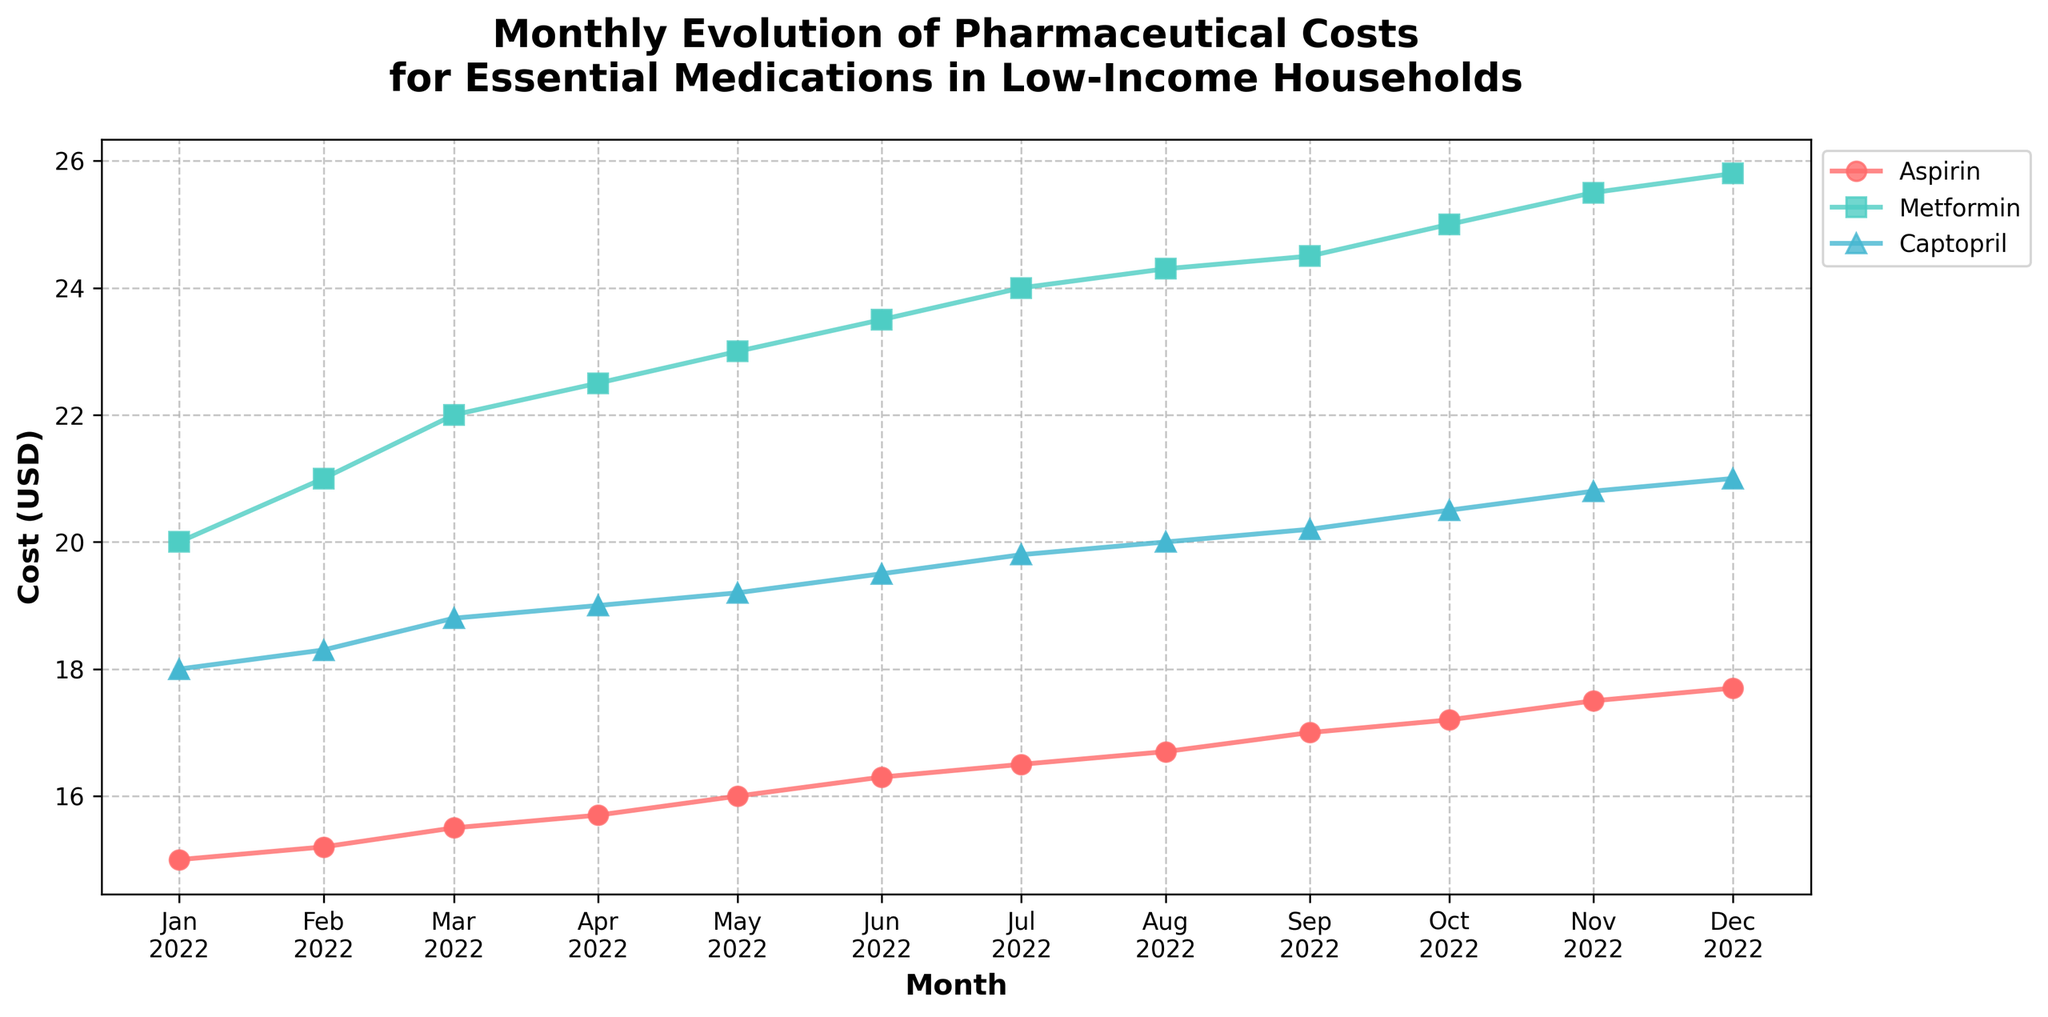What is the title of the plot? The title is usually located at the top of the chart. Here, it says: "Monthly Evolution of Pharmaceutical Costs for Essential Medications in Low-Income Households."
Answer: Monthly Evolution of Pharmaceutical Costs for Essential Medications in Low-Income Households What does the x-axis represent? The x-axis typically represents the time units in a time series plot. In this particular plot, it is labeled as "Month," representing different months of the year 2022.
Answer: Month What does the y-axis represent? The y-axis is usually labeled to denote what is being measured in the plot. Here, it is labeled as "Cost (USD)," indicating that it shows the cost of medications in US dollars.
Answer: Cost (USD) Which three medications are shown in the plot? By looking at the legend or the labels in the plot, you can see which medications are represented. Here, the three medications are Aspirin, Metformin, and Captopril.
Answer: Aspirin, Metformin, Captopril Which medication had the highest cost increase over the year? To find which medication had the highest cost increase, look at the starting and ending points of their cost lines in the plot. Metformin starts at $20.00 and ends at $25.80, an increase of $5.80, the highest among the three.
Answer: Metformin What is the cost of Captopril in March 2022? Find the data point for Captopril in March 2022 on the plot and note the corresponding y-axis value. The plot shows it to be $18.80.
Answer: $18.80 How did the cost of Aspirin change from January to December 2022? To determine the change, subtract the initial cost in January from the final cost in December. The cost of Aspirin increased from $15.00 to $17.70, an increase of $2.70.
Answer: $2.70 increase What trend do you see in the costs of all three medications over the year? Observing the plot lines for all three medications, they all show an upward trend, indicating that costs increased consistently over the year.
Answer: Upward trend Which month shows the first increase in the cost of Metformin? Locate the month on the x-axis where the line for Metformin first shows an increase. The plot shows the first increase between January and February, with the cost rising from $20.00 to $21.00.
Answer: February Between which two consecutive months did Captopril see the largest single-month increase, and what was the increase? To find this, compare the differences between consecutive months for Captopril’s cost. The largest increase is between January and February, from $18.00 to $18.30, an increase of $0.30.
Answer: January to February, $0.30 